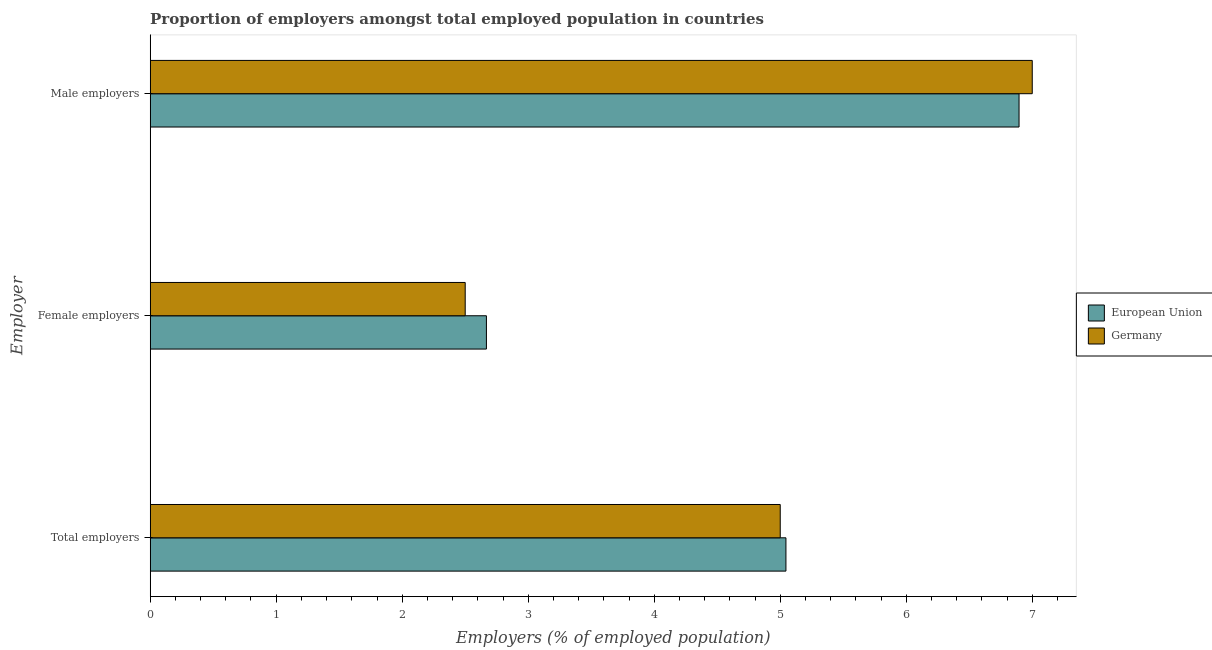Are the number of bars per tick equal to the number of legend labels?
Offer a very short reply. Yes. Are the number of bars on each tick of the Y-axis equal?
Your response must be concise. Yes. How many bars are there on the 3rd tick from the top?
Ensure brevity in your answer.  2. What is the label of the 1st group of bars from the top?
Give a very brief answer. Male employers. What is the percentage of female employers in European Union?
Offer a terse response. 2.67. Across all countries, what is the maximum percentage of total employers?
Offer a very short reply. 5.05. Across all countries, what is the minimum percentage of female employers?
Offer a terse response. 2.5. In which country was the percentage of total employers maximum?
Keep it short and to the point. European Union. What is the total percentage of total employers in the graph?
Ensure brevity in your answer.  10.05. What is the difference between the percentage of female employers in Germany and that in European Union?
Give a very brief answer. -0.17. What is the difference between the percentage of male employers in Germany and the percentage of female employers in European Union?
Give a very brief answer. 4.33. What is the average percentage of female employers per country?
Your response must be concise. 2.58. What is the difference between the percentage of male employers and percentage of female employers in European Union?
Offer a terse response. 4.23. In how many countries, is the percentage of male employers greater than 1.8 %?
Keep it short and to the point. 2. What is the ratio of the percentage of female employers in Germany to that in European Union?
Provide a short and direct response. 0.94. Is the difference between the percentage of total employers in Germany and European Union greater than the difference between the percentage of male employers in Germany and European Union?
Your answer should be compact. No. What is the difference between the highest and the second highest percentage of total employers?
Provide a short and direct response. 0.05. What is the difference between the highest and the lowest percentage of female employers?
Offer a terse response. 0.17. In how many countries, is the percentage of female employers greater than the average percentage of female employers taken over all countries?
Provide a short and direct response. 1. What does the 2nd bar from the top in Female employers represents?
Offer a terse response. European Union. What does the 1st bar from the bottom in Female employers represents?
Provide a succinct answer. European Union. How many bars are there?
Provide a short and direct response. 6. What is the difference between two consecutive major ticks on the X-axis?
Give a very brief answer. 1. Does the graph contain grids?
Give a very brief answer. No. What is the title of the graph?
Keep it short and to the point. Proportion of employers amongst total employed population in countries. What is the label or title of the X-axis?
Make the answer very short. Employers (% of employed population). What is the label or title of the Y-axis?
Make the answer very short. Employer. What is the Employers (% of employed population) in European Union in Total employers?
Keep it short and to the point. 5.05. What is the Employers (% of employed population) in European Union in Female employers?
Make the answer very short. 2.67. What is the Employers (% of employed population) in European Union in Male employers?
Your response must be concise. 6.9. Across all Employer, what is the maximum Employers (% of employed population) of European Union?
Provide a succinct answer. 6.9. Across all Employer, what is the minimum Employers (% of employed population) of European Union?
Your response must be concise. 2.67. What is the total Employers (% of employed population) in European Union in the graph?
Your answer should be compact. 14.61. What is the difference between the Employers (% of employed population) in European Union in Total employers and that in Female employers?
Ensure brevity in your answer.  2.38. What is the difference between the Employers (% of employed population) of Germany in Total employers and that in Female employers?
Provide a succinct answer. 2.5. What is the difference between the Employers (% of employed population) in European Union in Total employers and that in Male employers?
Provide a short and direct response. -1.85. What is the difference between the Employers (% of employed population) of European Union in Female employers and that in Male employers?
Give a very brief answer. -4.23. What is the difference between the Employers (% of employed population) of Germany in Female employers and that in Male employers?
Your answer should be very brief. -4.5. What is the difference between the Employers (% of employed population) of European Union in Total employers and the Employers (% of employed population) of Germany in Female employers?
Your answer should be compact. 2.55. What is the difference between the Employers (% of employed population) of European Union in Total employers and the Employers (% of employed population) of Germany in Male employers?
Ensure brevity in your answer.  -1.95. What is the difference between the Employers (% of employed population) in European Union in Female employers and the Employers (% of employed population) in Germany in Male employers?
Your answer should be compact. -4.33. What is the average Employers (% of employed population) of European Union per Employer?
Provide a short and direct response. 4.87. What is the average Employers (% of employed population) of Germany per Employer?
Offer a terse response. 4.83. What is the difference between the Employers (% of employed population) in European Union and Employers (% of employed population) in Germany in Total employers?
Offer a terse response. 0.05. What is the difference between the Employers (% of employed population) of European Union and Employers (% of employed population) of Germany in Female employers?
Ensure brevity in your answer.  0.17. What is the difference between the Employers (% of employed population) in European Union and Employers (% of employed population) in Germany in Male employers?
Offer a very short reply. -0.1. What is the ratio of the Employers (% of employed population) of European Union in Total employers to that in Female employers?
Provide a succinct answer. 1.89. What is the ratio of the Employers (% of employed population) in European Union in Total employers to that in Male employers?
Ensure brevity in your answer.  0.73. What is the ratio of the Employers (% of employed population) of Germany in Total employers to that in Male employers?
Your response must be concise. 0.71. What is the ratio of the Employers (% of employed population) of European Union in Female employers to that in Male employers?
Offer a terse response. 0.39. What is the ratio of the Employers (% of employed population) of Germany in Female employers to that in Male employers?
Provide a succinct answer. 0.36. What is the difference between the highest and the second highest Employers (% of employed population) of European Union?
Make the answer very short. 1.85. What is the difference between the highest and the lowest Employers (% of employed population) in European Union?
Your response must be concise. 4.23. What is the difference between the highest and the lowest Employers (% of employed population) of Germany?
Give a very brief answer. 4.5. 